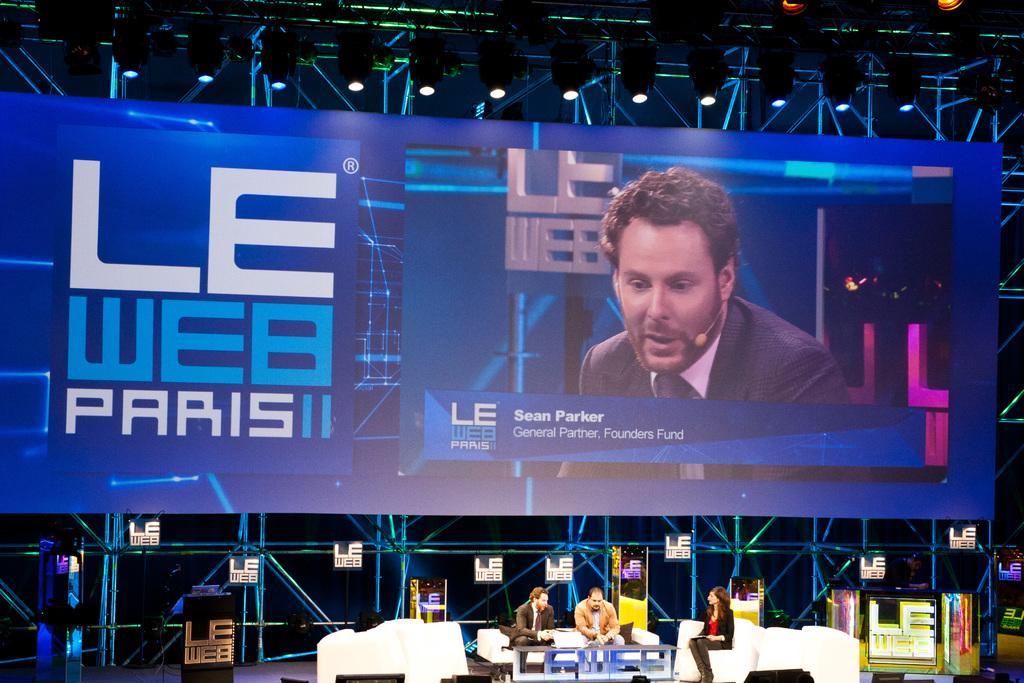How would you summarize this image in a sentence or two? It is looking like a stage. At the bottom of the image I can see two men and a woman are sitting on the chairs on the stage. In front of this people there is a table. In the background, I can see a banner which is in blue color. On this I can see some text and an image of a man. At the back of this I can see metal rods and lights. 